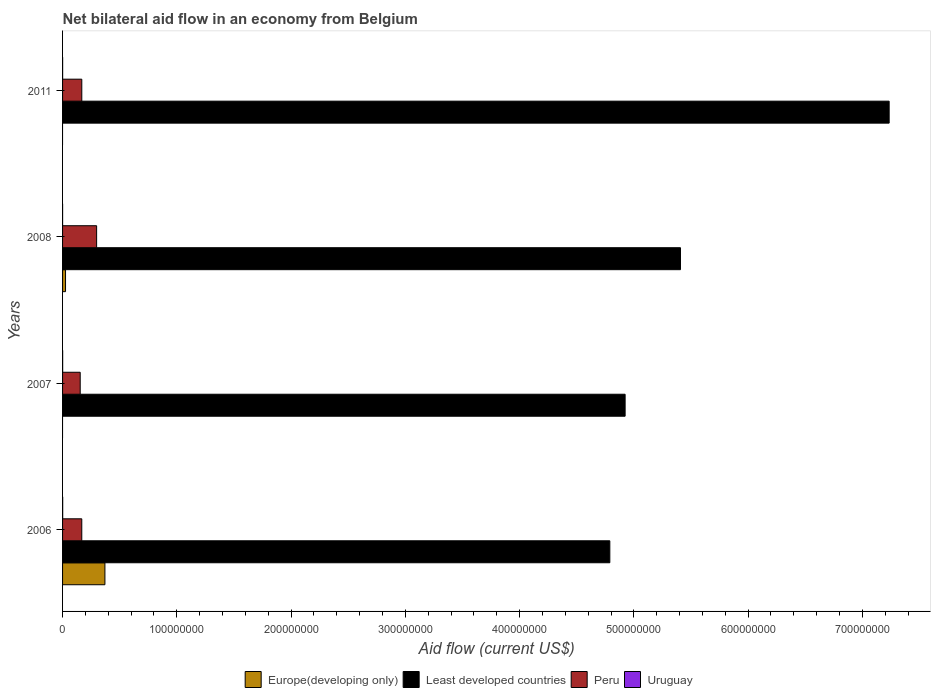How many different coloured bars are there?
Provide a short and direct response. 4. How many bars are there on the 1st tick from the bottom?
Provide a succinct answer. 4. In how many cases, is the number of bars for a given year not equal to the number of legend labels?
Provide a succinct answer. 2. What is the net bilateral aid flow in Uruguay in 2008?
Your answer should be very brief. 2.00e+04. Across all years, what is the minimum net bilateral aid flow in Uruguay?
Make the answer very short. 2.00e+04. In which year was the net bilateral aid flow in Europe(developing only) maximum?
Offer a terse response. 2006. What is the difference between the net bilateral aid flow in Peru in 2006 and that in 2008?
Give a very brief answer. -1.30e+07. What is the difference between the net bilateral aid flow in Peru in 2006 and the net bilateral aid flow in Least developed countries in 2008?
Offer a terse response. -5.24e+08. What is the average net bilateral aid flow in Europe(developing only) per year?
Offer a very short reply. 9.92e+06. In the year 2011, what is the difference between the net bilateral aid flow in Uruguay and net bilateral aid flow in Least developed countries?
Offer a terse response. -7.23e+08. What is the ratio of the net bilateral aid flow in Least developed countries in 2006 to that in 2011?
Give a very brief answer. 0.66. What is the difference between the highest and the second highest net bilateral aid flow in Uruguay?
Make the answer very short. 2.00e+04. What is the difference between the highest and the lowest net bilateral aid flow in Europe(developing only)?
Your answer should be compact. 3.71e+07. Is the sum of the net bilateral aid flow in Least developed countries in 2008 and 2011 greater than the maximum net bilateral aid flow in Uruguay across all years?
Your answer should be compact. Yes. How many bars are there?
Provide a short and direct response. 14. What is the difference between two consecutive major ticks on the X-axis?
Offer a terse response. 1.00e+08. Does the graph contain grids?
Your response must be concise. No. Where does the legend appear in the graph?
Provide a short and direct response. Bottom center. How many legend labels are there?
Offer a terse response. 4. What is the title of the graph?
Give a very brief answer. Net bilateral aid flow in an economy from Belgium. What is the label or title of the Y-axis?
Offer a terse response. Years. What is the Aid flow (current US$) of Europe(developing only) in 2006?
Ensure brevity in your answer.  3.71e+07. What is the Aid flow (current US$) of Least developed countries in 2006?
Offer a terse response. 4.79e+08. What is the Aid flow (current US$) in Peru in 2006?
Your answer should be compact. 1.68e+07. What is the Aid flow (current US$) in Least developed countries in 2007?
Keep it short and to the point. 4.92e+08. What is the Aid flow (current US$) in Peru in 2007?
Offer a terse response. 1.54e+07. What is the Aid flow (current US$) in Europe(developing only) in 2008?
Your answer should be very brief. 2.59e+06. What is the Aid flow (current US$) in Least developed countries in 2008?
Ensure brevity in your answer.  5.41e+08. What is the Aid flow (current US$) of Peru in 2008?
Provide a succinct answer. 2.98e+07. What is the Aid flow (current US$) in Least developed countries in 2011?
Give a very brief answer. 7.23e+08. What is the Aid flow (current US$) in Peru in 2011?
Your response must be concise. 1.68e+07. What is the Aid flow (current US$) of Uruguay in 2011?
Your answer should be very brief. 5.00e+04. Across all years, what is the maximum Aid flow (current US$) of Europe(developing only)?
Your response must be concise. 3.71e+07. Across all years, what is the maximum Aid flow (current US$) of Least developed countries?
Offer a very short reply. 7.23e+08. Across all years, what is the maximum Aid flow (current US$) of Peru?
Give a very brief answer. 2.98e+07. Across all years, what is the minimum Aid flow (current US$) of Europe(developing only)?
Offer a terse response. 0. Across all years, what is the minimum Aid flow (current US$) of Least developed countries?
Your response must be concise. 4.79e+08. Across all years, what is the minimum Aid flow (current US$) of Peru?
Your answer should be very brief. 1.54e+07. What is the total Aid flow (current US$) in Europe(developing only) in the graph?
Keep it short and to the point. 3.97e+07. What is the total Aid flow (current US$) of Least developed countries in the graph?
Offer a very short reply. 2.24e+09. What is the total Aid flow (current US$) in Peru in the graph?
Make the answer very short. 7.89e+07. What is the difference between the Aid flow (current US$) in Least developed countries in 2006 and that in 2007?
Your answer should be compact. -1.34e+07. What is the difference between the Aid flow (current US$) of Peru in 2006 and that in 2007?
Offer a very short reply. 1.38e+06. What is the difference between the Aid flow (current US$) of Europe(developing only) in 2006 and that in 2008?
Your response must be concise. 3.45e+07. What is the difference between the Aid flow (current US$) in Least developed countries in 2006 and that in 2008?
Offer a very short reply. -6.18e+07. What is the difference between the Aid flow (current US$) of Peru in 2006 and that in 2008?
Provide a succinct answer. -1.30e+07. What is the difference between the Aid flow (current US$) in Least developed countries in 2006 and that in 2011?
Give a very brief answer. -2.44e+08. What is the difference between the Aid flow (current US$) of Peru in 2006 and that in 2011?
Provide a succinct answer. -10000. What is the difference between the Aid flow (current US$) of Least developed countries in 2007 and that in 2008?
Make the answer very short. -4.85e+07. What is the difference between the Aid flow (current US$) of Peru in 2007 and that in 2008?
Your answer should be very brief. -1.44e+07. What is the difference between the Aid flow (current US$) in Uruguay in 2007 and that in 2008?
Keep it short and to the point. 6.00e+04. What is the difference between the Aid flow (current US$) of Least developed countries in 2007 and that in 2011?
Give a very brief answer. -2.31e+08. What is the difference between the Aid flow (current US$) in Peru in 2007 and that in 2011?
Provide a succinct answer. -1.39e+06. What is the difference between the Aid flow (current US$) of Least developed countries in 2008 and that in 2011?
Provide a succinct answer. -1.83e+08. What is the difference between the Aid flow (current US$) in Peru in 2008 and that in 2011?
Your answer should be very brief. 1.30e+07. What is the difference between the Aid flow (current US$) in Europe(developing only) in 2006 and the Aid flow (current US$) in Least developed countries in 2007?
Keep it short and to the point. -4.55e+08. What is the difference between the Aid flow (current US$) in Europe(developing only) in 2006 and the Aid flow (current US$) in Peru in 2007?
Provide a succinct answer. 2.16e+07. What is the difference between the Aid flow (current US$) in Europe(developing only) in 2006 and the Aid flow (current US$) in Uruguay in 2007?
Give a very brief answer. 3.70e+07. What is the difference between the Aid flow (current US$) in Least developed countries in 2006 and the Aid flow (current US$) in Peru in 2007?
Make the answer very short. 4.64e+08. What is the difference between the Aid flow (current US$) in Least developed countries in 2006 and the Aid flow (current US$) in Uruguay in 2007?
Offer a terse response. 4.79e+08. What is the difference between the Aid flow (current US$) in Peru in 2006 and the Aid flow (current US$) in Uruguay in 2007?
Keep it short and to the point. 1.67e+07. What is the difference between the Aid flow (current US$) in Europe(developing only) in 2006 and the Aid flow (current US$) in Least developed countries in 2008?
Give a very brief answer. -5.04e+08. What is the difference between the Aid flow (current US$) of Europe(developing only) in 2006 and the Aid flow (current US$) of Peru in 2008?
Your response must be concise. 7.26e+06. What is the difference between the Aid flow (current US$) of Europe(developing only) in 2006 and the Aid flow (current US$) of Uruguay in 2008?
Provide a short and direct response. 3.70e+07. What is the difference between the Aid flow (current US$) in Least developed countries in 2006 and the Aid flow (current US$) in Peru in 2008?
Your response must be concise. 4.49e+08. What is the difference between the Aid flow (current US$) of Least developed countries in 2006 and the Aid flow (current US$) of Uruguay in 2008?
Your answer should be compact. 4.79e+08. What is the difference between the Aid flow (current US$) of Peru in 2006 and the Aid flow (current US$) of Uruguay in 2008?
Offer a very short reply. 1.68e+07. What is the difference between the Aid flow (current US$) in Europe(developing only) in 2006 and the Aid flow (current US$) in Least developed countries in 2011?
Keep it short and to the point. -6.86e+08. What is the difference between the Aid flow (current US$) of Europe(developing only) in 2006 and the Aid flow (current US$) of Peru in 2011?
Offer a terse response. 2.02e+07. What is the difference between the Aid flow (current US$) in Europe(developing only) in 2006 and the Aid flow (current US$) in Uruguay in 2011?
Offer a terse response. 3.70e+07. What is the difference between the Aid flow (current US$) of Least developed countries in 2006 and the Aid flow (current US$) of Peru in 2011?
Your answer should be very brief. 4.62e+08. What is the difference between the Aid flow (current US$) of Least developed countries in 2006 and the Aid flow (current US$) of Uruguay in 2011?
Give a very brief answer. 4.79e+08. What is the difference between the Aid flow (current US$) in Peru in 2006 and the Aid flow (current US$) in Uruguay in 2011?
Your answer should be compact. 1.68e+07. What is the difference between the Aid flow (current US$) in Least developed countries in 2007 and the Aid flow (current US$) in Peru in 2008?
Make the answer very short. 4.63e+08. What is the difference between the Aid flow (current US$) in Least developed countries in 2007 and the Aid flow (current US$) in Uruguay in 2008?
Keep it short and to the point. 4.92e+08. What is the difference between the Aid flow (current US$) of Peru in 2007 and the Aid flow (current US$) of Uruguay in 2008?
Your response must be concise. 1.54e+07. What is the difference between the Aid flow (current US$) in Least developed countries in 2007 and the Aid flow (current US$) in Peru in 2011?
Your answer should be very brief. 4.76e+08. What is the difference between the Aid flow (current US$) in Least developed countries in 2007 and the Aid flow (current US$) in Uruguay in 2011?
Your answer should be compact. 4.92e+08. What is the difference between the Aid flow (current US$) of Peru in 2007 and the Aid flow (current US$) of Uruguay in 2011?
Make the answer very short. 1.54e+07. What is the difference between the Aid flow (current US$) in Europe(developing only) in 2008 and the Aid flow (current US$) in Least developed countries in 2011?
Your response must be concise. -7.21e+08. What is the difference between the Aid flow (current US$) of Europe(developing only) in 2008 and the Aid flow (current US$) of Peru in 2011?
Provide a short and direct response. -1.42e+07. What is the difference between the Aid flow (current US$) of Europe(developing only) in 2008 and the Aid flow (current US$) of Uruguay in 2011?
Give a very brief answer. 2.54e+06. What is the difference between the Aid flow (current US$) of Least developed countries in 2008 and the Aid flow (current US$) of Peru in 2011?
Your response must be concise. 5.24e+08. What is the difference between the Aid flow (current US$) of Least developed countries in 2008 and the Aid flow (current US$) of Uruguay in 2011?
Give a very brief answer. 5.41e+08. What is the difference between the Aid flow (current US$) in Peru in 2008 and the Aid flow (current US$) in Uruguay in 2011?
Offer a very short reply. 2.98e+07. What is the average Aid flow (current US$) in Europe(developing only) per year?
Provide a short and direct response. 9.92e+06. What is the average Aid flow (current US$) in Least developed countries per year?
Keep it short and to the point. 5.59e+08. What is the average Aid flow (current US$) of Peru per year?
Your answer should be compact. 1.97e+07. What is the average Aid flow (current US$) of Uruguay per year?
Give a very brief answer. 6.25e+04. In the year 2006, what is the difference between the Aid flow (current US$) of Europe(developing only) and Aid flow (current US$) of Least developed countries?
Keep it short and to the point. -4.42e+08. In the year 2006, what is the difference between the Aid flow (current US$) of Europe(developing only) and Aid flow (current US$) of Peru?
Your answer should be compact. 2.02e+07. In the year 2006, what is the difference between the Aid flow (current US$) in Europe(developing only) and Aid flow (current US$) in Uruguay?
Keep it short and to the point. 3.70e+07. In the year 2006, what is the difference between the Aid flow (current US$) in Least developed countries and Aid flow (current US$) in Peru?
Your answer should be compact. 4.62e+08. In the year 2006, what is the difference between the Aid flow (current US$) in Least developed countries and Aid flow (current US$) in Uruguay?
Provide a short and direct response. 4.79e+08. In the year 2006, what is the difference between the Aid flow (current US$) in Peru and Aid flow (current US$) in Uruguay?
Provide a succinct answer. 1.67e+07. In the year 2007, what is the difference between the Aid flow (current US$) of Least developed countries and Aid flow (current US$) of Peru?
Give a very brief answer. 4.77e+08. In the year 2007, what is the difference between the Aid flow (current US$) in Least developed countries and Aid flow (current US$) in Uruguay?
Provide a succinct answer. 4.92e+08. In the year 2007, what is the difference between the Aid flow (current US$) in Peru and Aid flow (current US$) in Uruguay?
Your answer should be compact. 1.54e+07. In the year 2008, what is the difference between the Aid flow (current US$) of Europe(developing only) and Aid flow (current US$) of Least developed countries?
Provide a short and direct response. -5.38e+08. In the year 2008, what is the difference between the Aid flow (current US$) of Europe(developing only) and Aid flow (current US$) of Peru?
Make the answer very short. -2.72e+07. In the year 2008, what is the difference between the Aid flow (current US$) in Europe(developing only) and Aid flow (current US$) in Uruguay?
Keep it short and to the point. 2.57e+06. In the year 2008, what is the difference between the Aid flow (current US$) of Least developed countries and Aid flow (current US$) of Peru?
Your answer should be compact. 5.11e+08. In the year 2008, what is the difference between the Aid flow (current US$) of Least developed countries and Aid flow (current US$) of Uruguay?
Provide a short and direct response. 5.41e+08. In the year 2008, what is the difference between the Aid flow (current US$) in Peru and Aid flow (current US$) in Uruguay?
Offer a terse response. 2.98e+07. In the year 2011, what is the difference between the Aid flow (current US$) in Least developed countries and Aid flow (current US$) in Peru?
Your answer should be very brief. 7.07e+08. In the year 2011, what is the difference between the Aid flow (current US$) in Least developed countries and Aid flow (current US$) in Uruguay?
Offer a terse response. 7.23e+08. In the year 2011, what is the difference between the Aid flow (current US$) of Peru and Aid flow (current US$) of Uruguay?
Make the answer very short. 1.68e+07. What is the ratio of the Aid flow (current US$) of Least developed countries in 2006 to that in 2007?
Make the answer very short. 0.97. What is the ratio of the Aid flow (current US$) of Peru in 2006 to that in 2007?
Your answer should be very brief. 1.09. What is the ratio of the Aid flow (current US$) of Uruguay in 2006 to that in 2007?
Ensure brevity in your answer.  1.25. What is the ratio of the Aid flow (current US$) of Europe(developing only) in 2006 to that in 2008?
Your answer should be compact. 14.31. What is the ratio of the Aid flow (current US$) in Least developed countries in 2006 to that in 2008?
Offer a very short reply. 0.89. What is the ratio of the Aid flow (current US$) in Peru in 2006 to that in 2008?
Your answer should be compact. 0.56. What is the ratio of the Aid flow (current US$) of Uruguay in 2006 to that in 2008?
Give a very brief answer. 5. What is the ratio of the Aid flow (current US$) in Least developed countries in 2006 to that in 2011?
Your response must be concise. 0.66. What is the ratio of the Aid flow (current US$) in Peru in 2006 to that in 2011?
Your response must be concise. 1. What is the ratio of the Aid flow (current US$) of Uruguay in 2006 to that in 2011?
Ensure brevity in your answer.  2. What is the ratio of the Aid flow (current US$) of Least developed countries in 2007 to that in 2008?
Provide a succinct answer. 0.91. What is the ratio of the Aid flow (current US$) in Peru in 2007 to that in 2008?
Your answer should be compact. 0.52. What is the ratio of the Aid flow (current US$) in Least developed countries in 2007 to that in 2011?
Your answer should be very brief. 0.68. What is the ratio of the Aid flow (current US$) of Peru in 2007 to that in 2011?
Offer a very short reply. 0.92. What is the ratio of the Aid flow (current US$) of Uruguay in 2007 to that in 2011?
Give a very brief answer. 1.6. What is the ratio of the Aid flow (current US$) in Least developed countries in 2008 to that in 2011?
Offer a very short reply. 0.75. What is the ratio of the Aid flow (current US$) of Peru in 2008 to that in 2011?
Offer a very short reply. 1.77. What is the difference between the highest and the second highest Aid flow (current US$) of Least developed countries?
Offer a very short reply. 1.83e+08. What is the difference between the highest and the second highest Aid flow (current US$) in Peru?
Make the answer very short. 1.30e+07. What is the difference between the highest and the second highest Aid flow (current US$) in Uruguay?
Your answer should be very brief. 2.00e+04. What is the difference between the highest and the lowest Aid flow (current US$) in Europe(developing only)?
Keep it short and to the point. 3.71e+07. What is the difference between the highest and the lowest Aid flow (current US$) of Least developed countries?
Keep it short and to the point. 2.44e+08. What is the difference between the highest and the lowest Aid flow (current US$) in Peru?
Keep it short and to the point. 1.44e+07. 